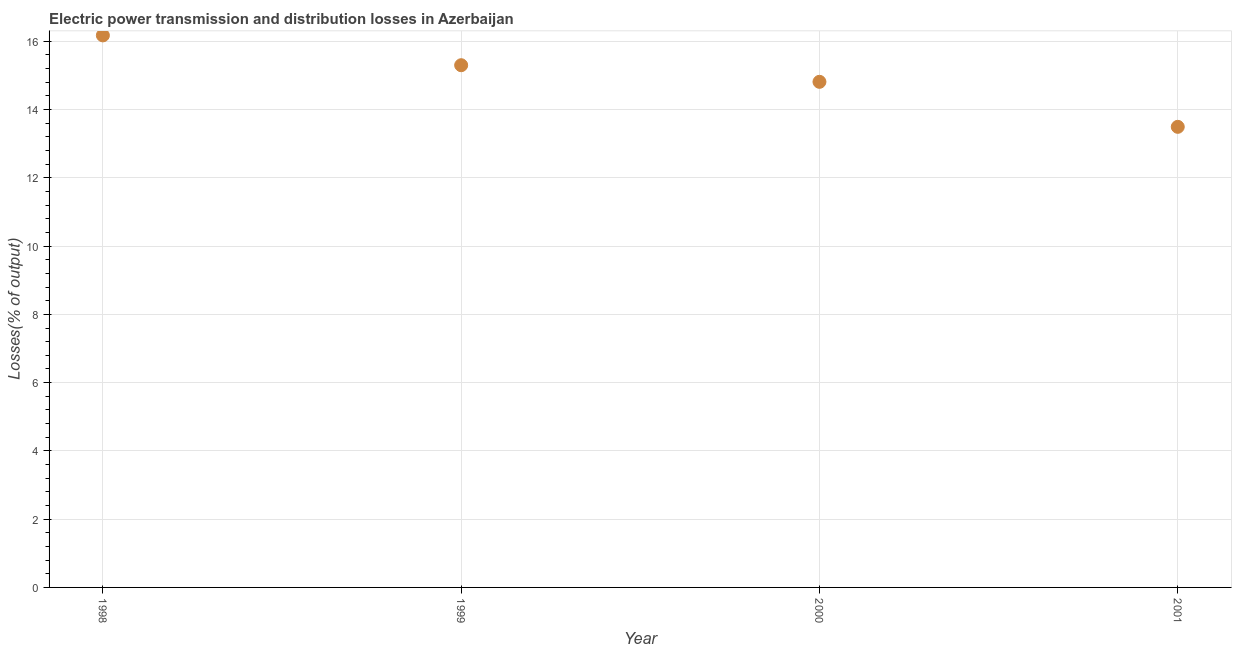What is the electric power transmission and distribution losses in 2001?
Ensure brevity in your answer.  13.49. Across all years, what is the maximum electric power transmission and distribution losses?
Your answer should be compact. 16.17. Across all years, what is the minimum electric power transmission and distribution losses?
Provide a short and direct response. 13.49. What is the sum of the electric power transmission and distribution losses?
Provide a succinct answer. 59.78. What is the difference between the electric power transmission and distribution losses in 1999 and 2000?
Give a very brief answer. 0.49. What is the average electric power transmission and distribution losses per year?
Give a very brief answer. 14.95. What is the median electric power transmission and distribution losses?
Provide a short and direct response. 15.06. In how many years, is the electric power transmission and distribution losses greater than 10 %?
Provide a short and direct response. 4. What is the ratio of the electric power transmission and distribution losses in 1999 to that in 2001?
Your answer should be very brief. 1.13. Is the electric power transmission and distribution losses in 1999 less than that in 2000?
Make the answer very short. No. Is the difference between the electric power transmission and distribution losses in 1998 and 2001 greater than the difference between any two years?
Keep it short and to the point. Yes. What is the difference between the highest and the second highest electric power transmission and distribution losses?
Offer a terse response. 0.87. What is the difference between the highest and the lowest electric power transmission and distribution losses?
Your response must be concise. 2.68. How many dotlines are there?
Provide a short and direct response. 1. How many years are there in the graph?
Your response must be concise. 4. Are the values on the major ticks of Y-axis written in scientific E-notation?
Your answer should be compact. No. Does the graph contain any zero values?
Provide a succinct answer. No. Does the graph contain grids?
Keep it short and to the point. Yes. What is the title of the graph?
Give a very brief answer. Electric power transmission and distribution losses in Azerbaijan. What is the label or title of the X-axis?
Offer a very short reply. Year. What is the label or title of the Y-axis?
Make the answer very short. Losses(% of output). What is the Losses(% of output) in 1998?
Ensure brevity in your answer.  16.17. What is the Losses(% of output) in 1999?
Make the answer very short. 15.3. What is the Losses(% of output) in 2000?
Give a very brief answer. 14.81. What is the Losses(% of output) in 2001?
Provide a short and direct response. 13.49. What is the difference between the Losses(% of output) in 1998 and 1999?
Your response must be concise. 0.87. What is the difference between the Losses(% of output) in 1998 and 2000?
Offer a very short reply. 1.36. What is the difference between the Losses(% of output) in 1998 and 2001?
Your response must be concise. 2.68. What is the difference between the Losses(% of output) in 1999 and 2000?
Give a very brief answer. 0.49. What is the difference between the Losses(% of output) in 1999 and 2001?
Provide a succinct answer. 1.81. What is the difference between the Losses(% of output) in 2000 and 2001?
Make the answer very short. 1.32. What is the ratio of the Losses(% of output) in 1998 to that in 1999?
Provide a short and direct response. 1.06. What is the ratio of the Losses(% of output) in 1998 to that in 2000?
Your answer should be compact. 1.09. What is the ratio of the Losses(% of output) in 1998 to that in 2001?
Your response must be concise. 1.2. What is the ratio of the Losses(% of output) in 1999 to that in 2000?
Give a very brief answer. 1.03. What is the ratio of the Losses(% of output) in 1999 to that in 2001?
Give a very brief answer. 1.13. What is the ratio of the Losses(% of output) in 2000 to that in 2001?
Make the answer very short. 1.1. 